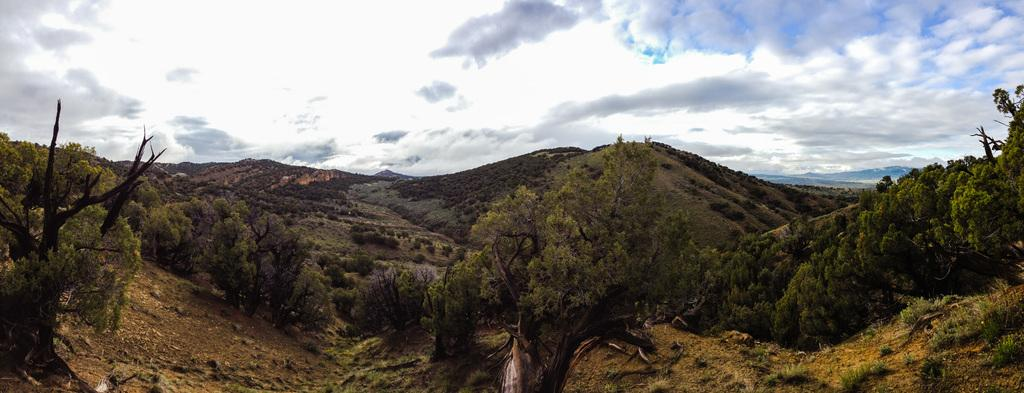What type of natural environment is depicted in the image? The image features many trees, mountains, and clouds. What color is the sky in the image? The sky is blue in the image. What type of bait is being used to catch fish in the image? There is no fishing or bait present in the image; it features trees, mountains, clouds, and a blue sky. 